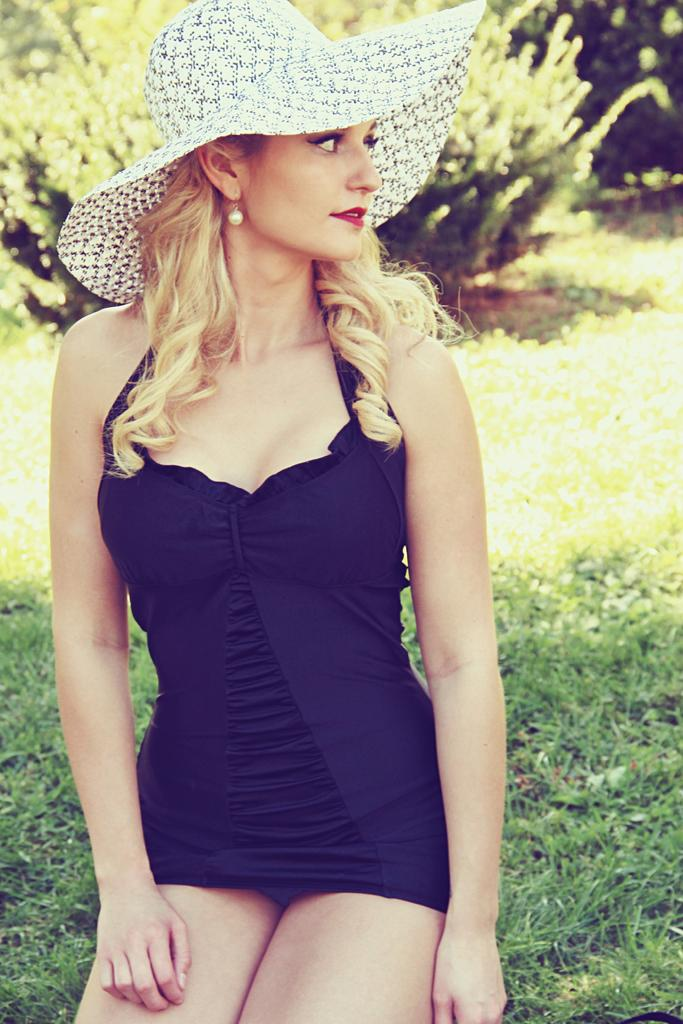Who is present in the image? There is a woman in the image. What is the woman wearing on her lower body? The woman is wearing a blue skirt. What is the woman wearing on her head? The woman is wearing a white cap on her head. What type of surface is the woman standing on? The woman is visible on grass. What can be seen in the background of the image? There are bushes in the background of the image. What type of vase is visible on the woman's head in the image? There is no vase present on the woman's head in the image; she is wearing a white cap. What type of truck can be seen driving through the bushes in the background? There is no truck visible in the image; only bushes are present in the background. 